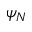Convert formula to latex. <formula><loc_0><loc_0><loc_500><loc_500>\psi _ { N }</formula> 